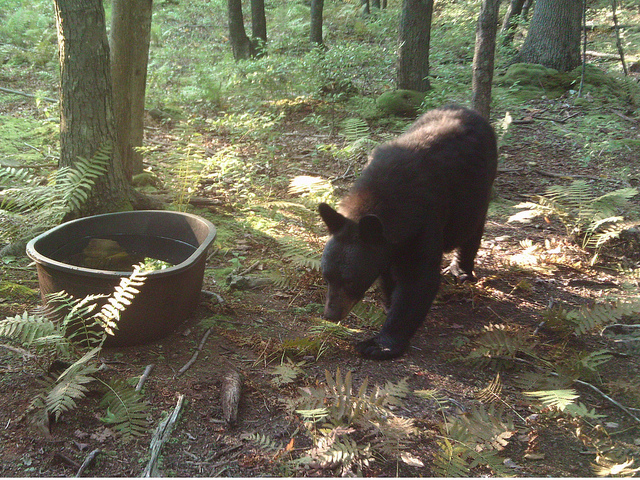<image>How much does the bear weigh? I don't know how much the bear weighs. It can vary greatly, estimates include 100 lbs, 175 lbs, 200 lbs, and 350 lbs. How much does the bear weigh? I am not sure how much the bear weighs. It can be around 200 pounds or 350 lbs. 